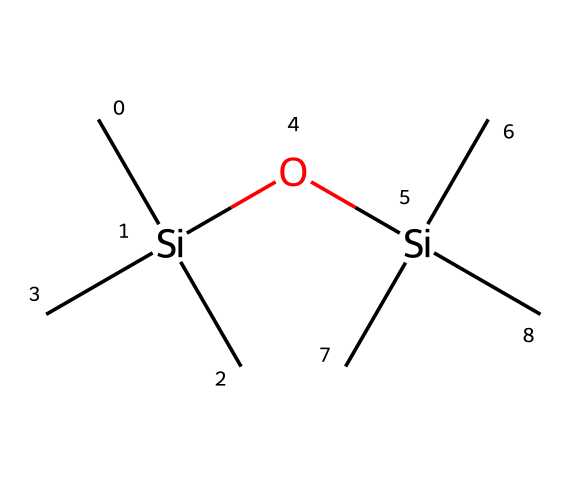What is the main functional group present in this chemical? The chemical contains silicon and oxygen atoms, typically indicating the presence of siloxane groups, which are characterized by the Si-O bonds.
Answer: siloxane How many silicon atoms are in this structure? Counting the silicon symbols in the SMILES, there are two silicon atoms, as each Si is represented by a 'Si' in the formula.
Answer: two What is the total count of carbon atoms in this compound? The SMILES notation shows that there are six carbon atoms in total, observed through each 'C' in the structure.
Answer: six How many oxygen atoms are included in this compound? The chemical structure includes two oxygen atoms since there are two instances of 'O'.
Answer: two What type of chemical reaction is likely facilitated by the siloxane groups in food preservation? Siloxane groups can facilitate hydration reactions, which are useful in stabilizing food systems and preventing spoilage.
Answer: hydration Which feature in the structure suggests it is organosilicon? The presence of silicon (Si) in the structure makes it distinctly an organosilicon compound, differentiating it from other organic compounds that do not contain silicon.
Answer: silicon What role do the alkyl groups play in this compound? The alkyl groups provide hydrophobic characteristics, enhancing the stability and effectiveness of the compound as a food preservative.
Answer: hydrophobic 